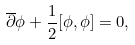Convert formula to latex. <formula><loc_0><loc_0><loc_500><loc_500>\overline { \partial } \phi + \frac { 1 } { 2 } [ \phi , \phi ] = 0 ,</formula> 